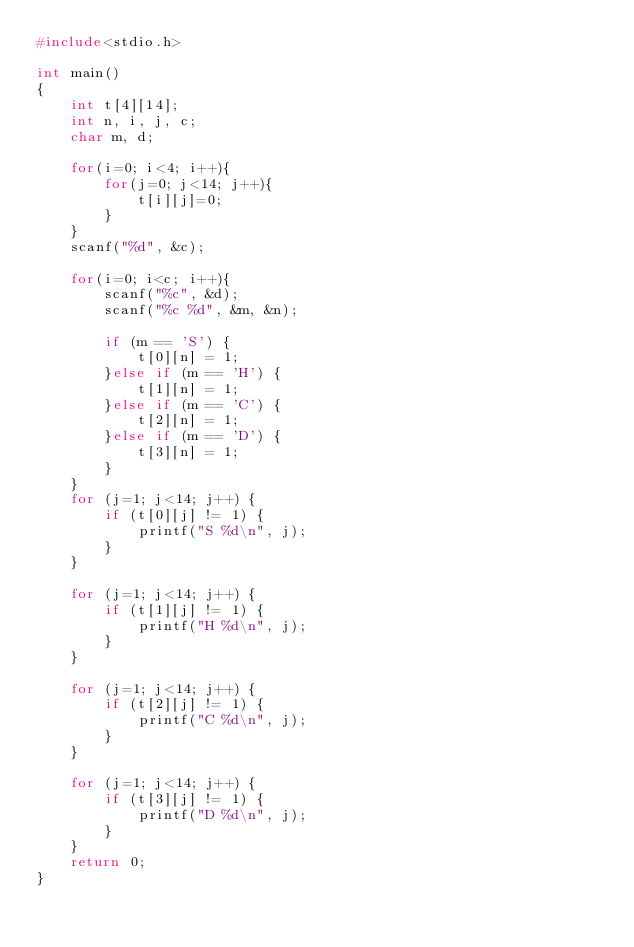<code> <loc_0><loc_0><loc_500><loc_500><_C_>#include<stdio.h>

int main()
{
    int t[4][14];
    int n, i, j, c;
    char m, d;
    
    for(i=0; i<4; i++){
        for(j=0; j<14; j++){
            t[i][j]=0;
        }
    }
    scanf("%d", &c);
    
    for(i=0; i<c; i++){
        scanf("%c", &d);
        scanf("%c %d", &m, &n);
        
        if (m == 'S') {
            t[0][n] = 1;
        }else if (m == 'H') {
            t[1][n] = 1;
        }else if (m == 'C') {
            t[2][n] = 1;
        }else if (m == 'D') {
            t[3][n] = 1;
        }
    }
    for (j=1; j<14; j++) {
        if (t[0][j] != 1) {
            printf("S %d\n", j);
        }
    }
    
    for (j=1; j<14; j++) {
        if (t[1][j] != 1) {
            printf("H %d\n", j);
        }
    }
    
    for (j=1; j<14; j++) {
        if (t[2][j] != 1) {
            printf("C %d\n", j);
        }
    }
    
    for (j=1; j<14; j++) {
        if (t[3][j] != 1) {
            printf("D %d\n", j);
        }
    }
    return 0;
}

</code> 